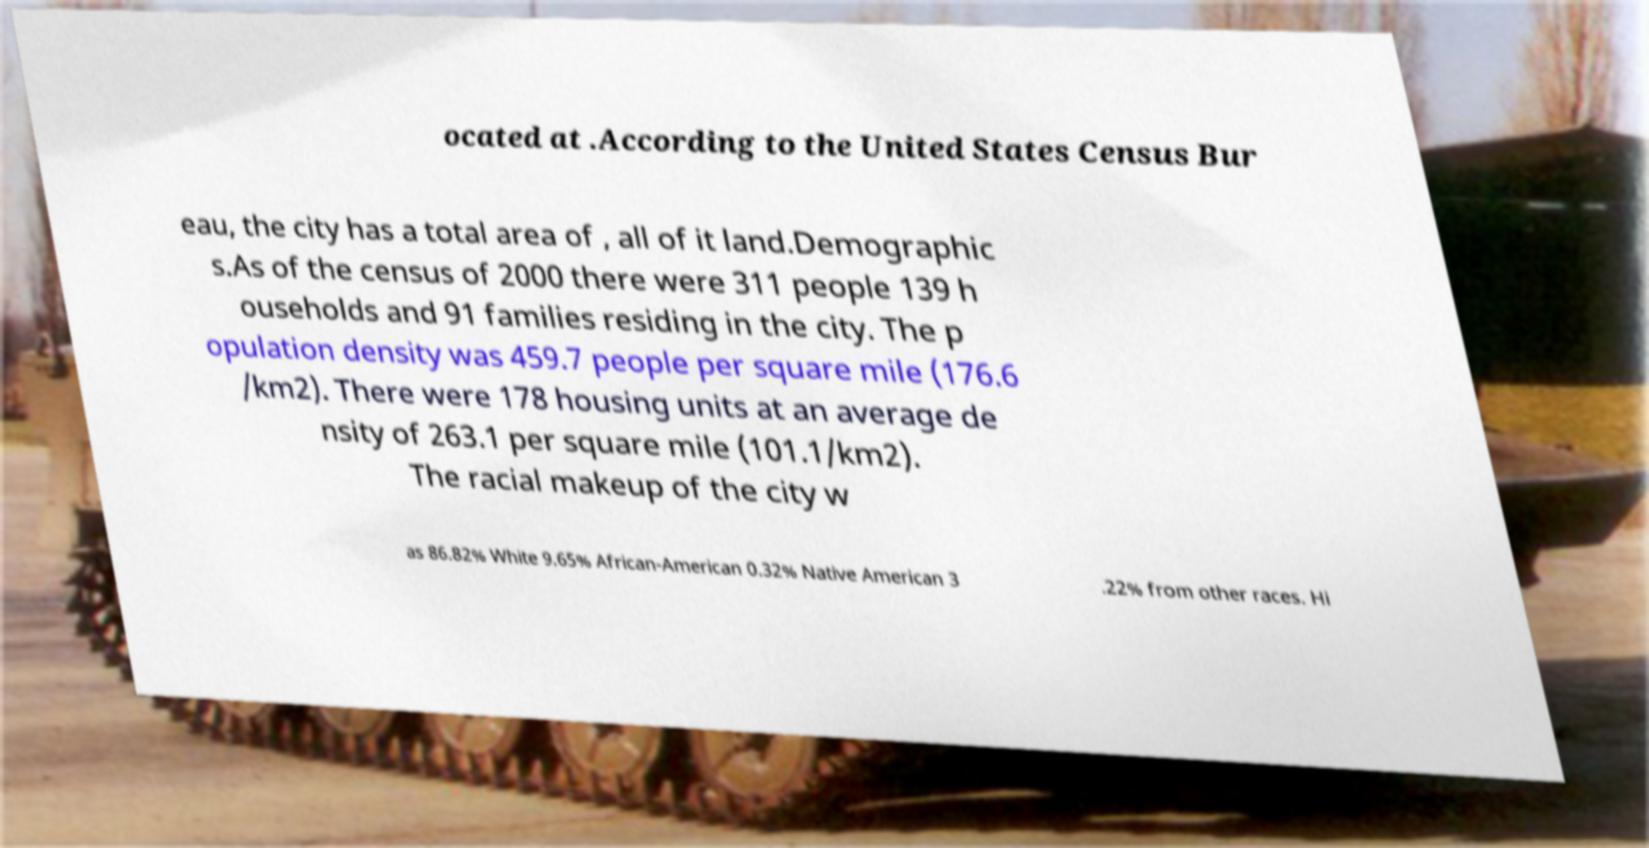Can you accurately transcribe the text from the provided image for me? ocated at .According to the United States Census Bur eau, the city has a total area of , all of it land.Demographic s.As of the census of 2000 there were 311 people 139 h ouseholds and 91 families residing in the city. The p opulation density was 459.7 people per square mile (176.6 /km2). There were 178 housing units at an average de nsity of 263.1 per square mile (101.1/km2). The racial makeup of the city w as 86.82% White 9.65% African-American 0.32% Native American 3 .22% from other races. Hi 